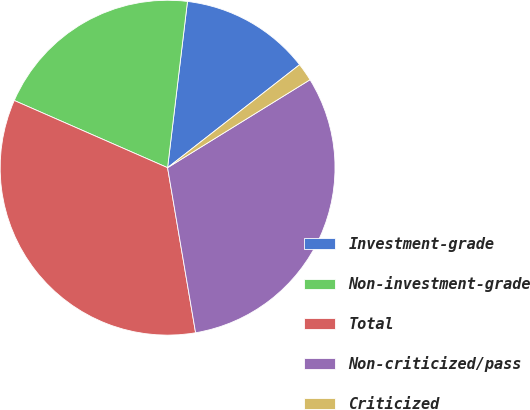Convert chart. <chart><loc_0><loc_0><loc_500><loc_500><pie_chart><fcel>Investment-grade<fcel>Non-investment-grade<fcel>Total<fcel>Non-criticized/pass<fcel>Criticized<nl><fcel>12.56%<fcel>20.32%<fcel>34.25%<fcel>31.13%<fcel>1.74%<nl></chart> 